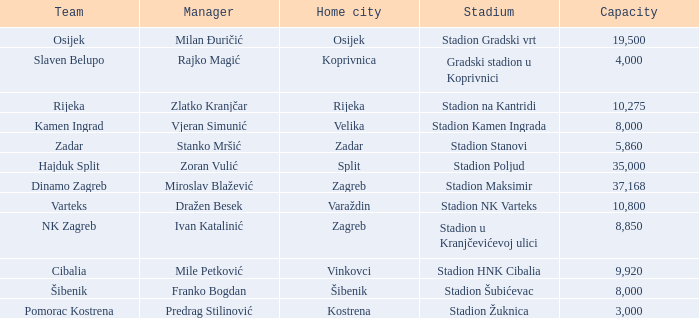Could you parse the entire table? {'header': ['Team', 'Manager', 'Home city', 'Stadium', 'Capacity'], 'rows': [['Osijek', 'Milan Đuričić', 'Osijek', 'Stadion Gradski vrt', '19,500'], ['Slaven Belupo', 'Rajko Magić', 'Koprivnica', 'Gradski stadion u Koprivnici', '4,000'], ['Rijeka', 'Zlatko Kranjčar', 'Rijeka', 'Stadion na Kantridi', '10,275'], ['Kamen Ingrad', 'Vjeran Simunić', 'Velika', 'Stadion Kamen Ingrada', '8,000'], ['Zadar', 'Stanko Mršić', 'Zadar', 'Stadion Stanovi', '5,860'], ['Hajduk Split', 'Zoran Vulić', 'Split', 'Stadion Poljud', '35,000'], ['Dinamo Zagreb', 'Miroslav Blažević', 'Zagreb', 'Stadion Maksimir', '37,168'], ['Varteks', 'Dražen Besek', 'Varaždin', 'Stadion NK Varteks', '10,800'], ['NK Zagreb', 'Ivan Katalinić', 'Zagreb', 'Stadion u Kranjčevićevoj ulici', '8,850'], ['Cibalia', 'Mile Petković', 'Vinkovci', 'Stadion HNK Cibalia', '9,920'], ['Šibenik', 'Franko Bogdan', 'Šibenik', 'Stadion Šubićevac', '8,000'], ['Pomorac Kostrena', 'Predrag Stilinović', 'Kostrena', 'Stadion Žuknica', '3,000']]} What team has a home city of Koprivnica? Slaven Belupo. 